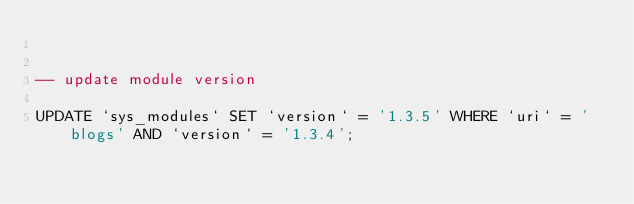<code> <loc_0><loc_0><loc_500><loc_500><_SQL_>

-- update module version

UPDATE `sys_modules` SET `version` = '1.3.5' WHERE `uri` = 'blogs' AND `version` = '1.3.4';

</code> 